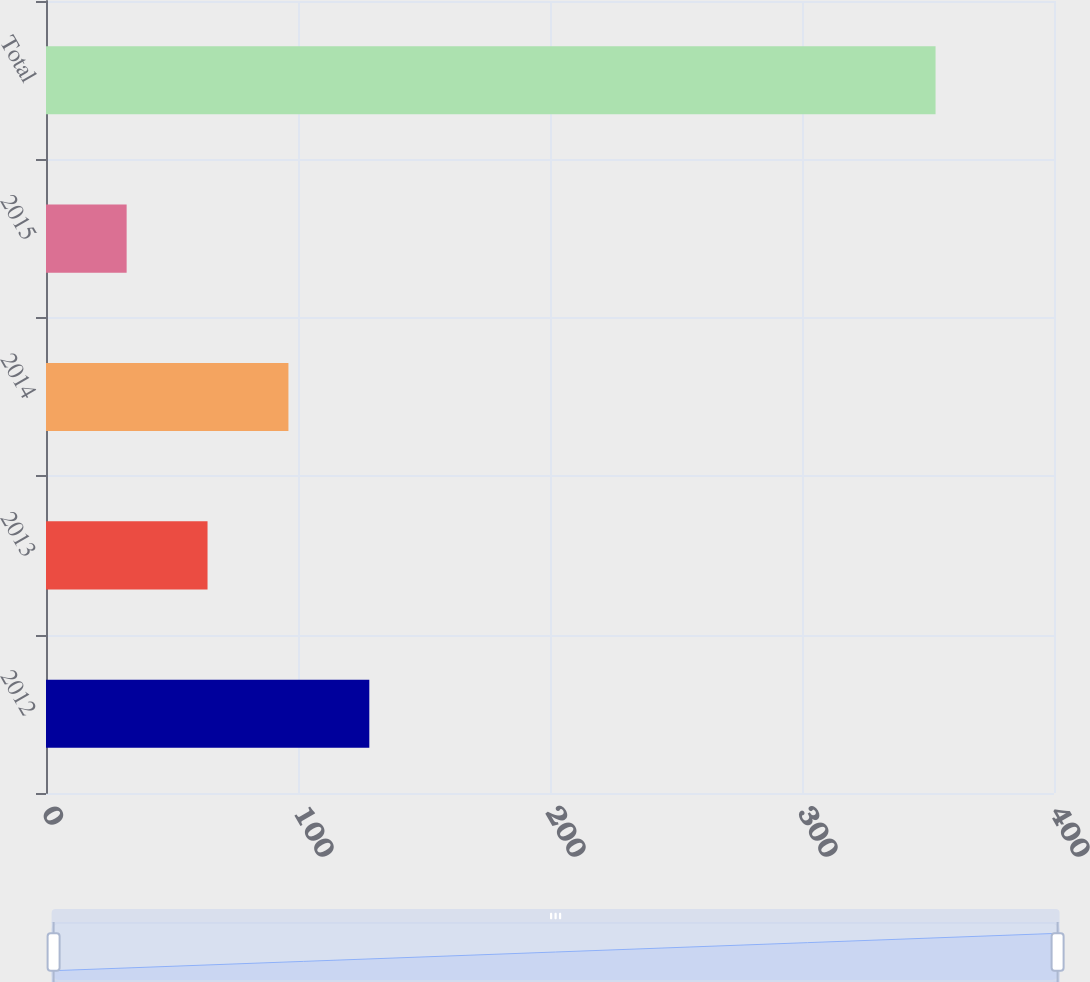Convert chart to OTSL. <chart><loc_0><loc_0><loc_500><loc_500><bar_chart><fcel>2012<fcel>2013<fcel>2014<fcel>2015<fcel>Total<nl><fcel>128.3<fcel>64.1<fcel>96.2<fcel>32<fcel>353<nl></chart> 